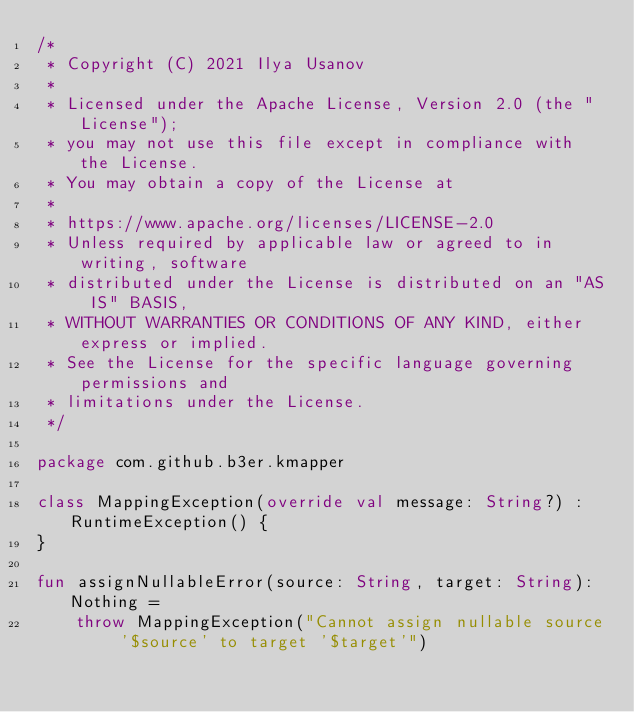<code> <loc_0><loc_0><loc_500><loc_500><_Kotlin_>/*
 * Copyright (C) 2021 Ilya Usanov
 *
 * Licensed under the Apache License, Version 2.0 (the "License");
 * you may not use this file except in compliance with the License.
 * You may obtain a copy of the License at
 *
 * https://www.apache.org/licenses/LICENSE-2.0
 * Unless required by applicable law or agreed to in writing, software
 * distributed under the License is distributed on an "AS IS" BASIS,
 * WITHOUT WARRANTIES OR CONDITIONS OF ANY KIND, either express or implied.
 * See the License for the specific language governing permissions and
 * limitations under the License.
 */

package com.github.b3er.kmapper

class MappingException(override val message: String?) : RuntimeException() {
}

fun assignNullableError(source: String, target: String): Nothing =
    throw MappingException("Cannot assign nullable source '$source' to target '$target'")
</code> 